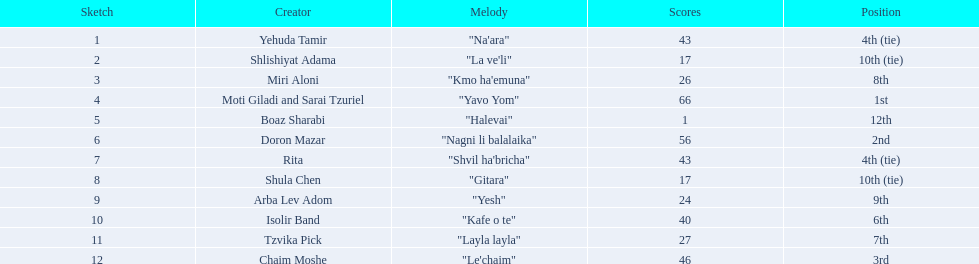What are the points in the competition? 43, 17, 26, 66, 1, 56, 43, 17, 24, 40, 27, 46. What is the lowest points? 1. What artist received these points? Boaz Sharabi. 